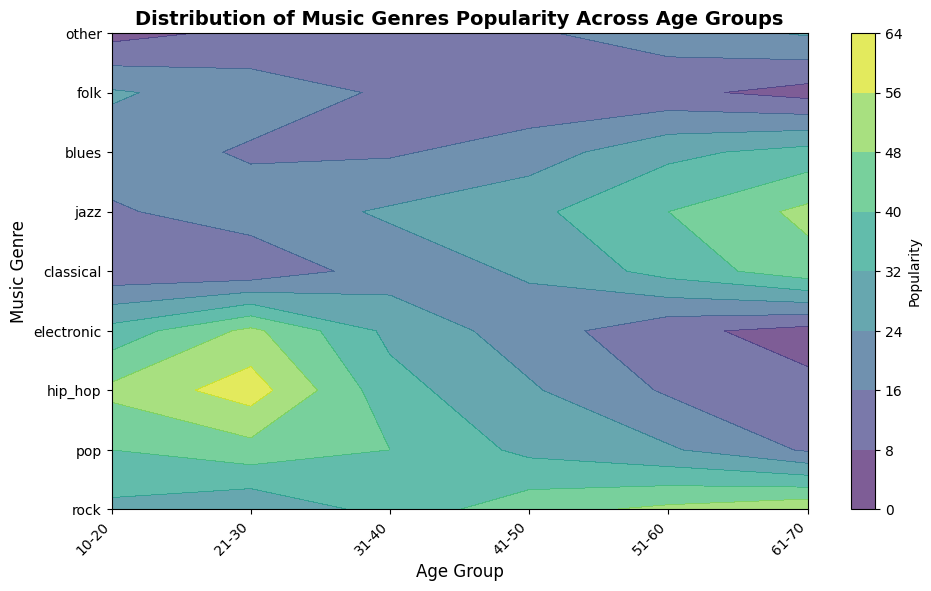What age group finds hip hop the most popular? Looking at the hip hop genre, the color intensity is highest at the 21-30 age group, indicating the highest popularity there.
Answer: 21-30 Which genre shows a consistent increase in popularity with age? By examining the contour plot, the color intensity for the genre 'classical' consistently increases from the youngest age group to the oldest, indicating a steady rise in popularity.
Answer: Classical Between ages 41-50 and 51-60, which group prefers jazz more? The contour hue indicating jazz popularity is more intense at the 51-60 age group than the 41-50 age group, signifying a higher preference in the former.
Answer: 51-60 What is the average popularity of rock music across all age groups? Checking the color intensities for the rock genre across all age groups and averaging those values: (30 + 25 + 35 + 45 + 50 + 55)/6 = 40.
Answer: 40 Comparatively, do the 10-20 or 61-70 age groups enjoy electronic music more? The color hue for electronic music is noticeably more intense in the 10-20 age group than in the 61-70 age group, signifying higher popularity.
Answer: 10-20 Which age group responds more to folk music, the 31-40 or the 51-60 group? Observing the plot, the color intensity for folk music is slightly more for the 31-40 age group compared to the 51-60 age group.
Answer: 31-40 What is the sum of popularity scores for other music genres for age groups 21-30 and 61-70? Adding the values: For 21-30, it’s 10, and for 61-70, it’s 25 resulting in a total of 10 + 25 = 35.
Answer: 35 In which age group does blues music reach a peak in popularity? The contour plot shows the highest color intensity for blues music in the 61-70 age group.
Answer: 61-70 Which genre is least popular among the 31-40 age group? For the 31-40 age group, the color intensity is lowest for the ‘other’ genre.
Answer: Other 